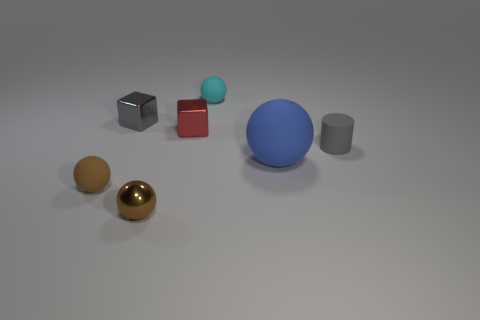There is a large matte sphere; is it the same color as the sphere that is in front of the small brown matte object?
Offer a very short reply. No. The cyan object has what shape?
Provide a succinct answer. Sphere. There is a gray object that is to the right of the small cyan thing right of the gray thing behind the small red cube; how big is it?
Give a very brief answer. Small. How many other things are there of the same shape as the gray matte object?
Make the answer very short. 0. Does the tiny red object in front of the gray shiny block have the same shape as the tiny gray thing that is right of the small gray shiny block?
Keep it short and to the point. No. What number of cubes are either gray objects or tiny yellow objects?
Ensure brevity in your answer.  1. There is a tiny object to the right of the small cyan sphere left of the large rubber thing in front of the red object; what is it made of?
Ensure brevity in your answer.  Rubber. What number of other objects are the same size as the red metal block?
Make the answer very short. 5. There is a rubber object that is the same color as the metal ball; what is its size?
Offer a very short reply. Small. Is the number of tiny matte cylinders behind the tiny cyan thing greater than the number of blue balls?
Ensure brevity in your answer.  No. 